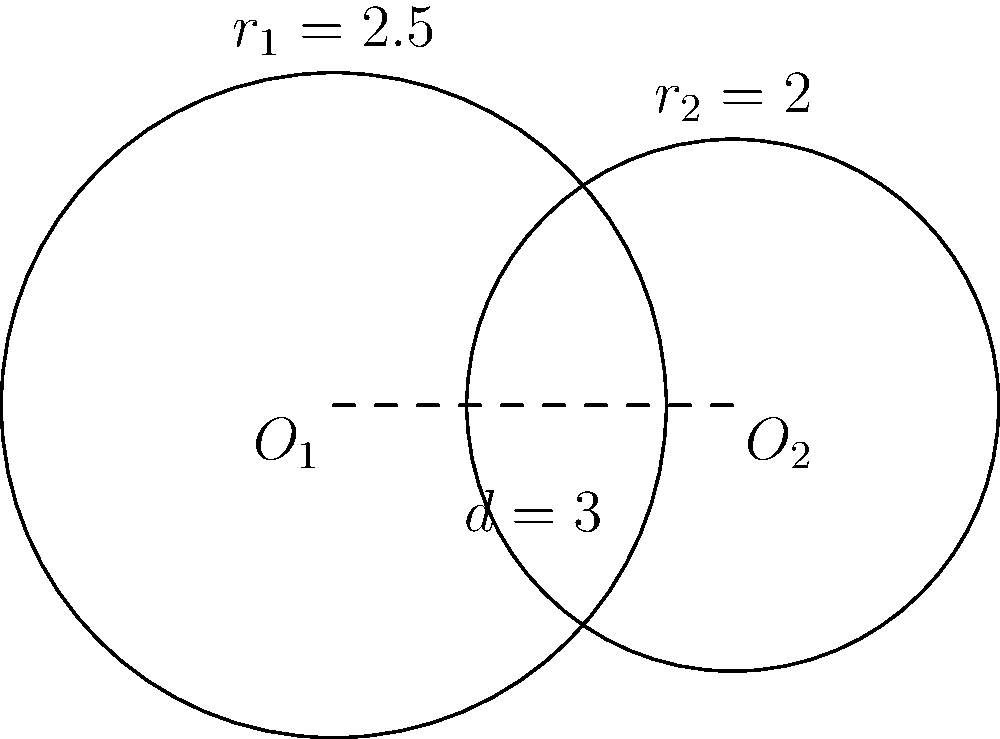In a groundbreaking investigative report by Elói Zorzetto, two circular surveillance zones are depicted as intersecting circles. The centers of these circles, $O_1$ and $O_2$, are 3 units apart. The radius of the larger circle ($r_1$) is 2.5 units, while the radius of the smaller circle ($r_2$) is 2 units. Calculate the area of the overlapping region between these two surveillance zones. To find the area of overlap between two intersecting circles, we'll follow these steps:

1) First, we need to calculate the angle $\theta$ at the center of each circle formed by the line joining the centers and the line to an intersection point.

   For circle 1: $\cos \theta_1 = \frac{r_1^2 + d^2 - r_2^2}{2r_1d}$
   
   For circle 2: $\cos \theta_2 = \frac{r_2^2 + d^2 - r_1^2}{2r_2d}$

   Where $d$ is the distance between centers.

2) Calculate $\theta_1$:
   $\cos \theta_1 = \frac{2.5^2 + 3^2 - 2^2}{2(2.5)(3)} = \frac{6.25 + 9 - 4}{15} = \frac{11.25}{15} = 0.75$
   $\theta_1 = \arccos(0.75) \approx 0.7227$ radians

3) Calculate $\theta_2$:
   $\cos \theta_2 = \frac{2^2 + 3^2 - 2.5^2}{2(2)(3)} = \frac{4 + 9 - 6.25}{12} = \frac{6.75}{12} = 0.5625$
   $\theta_2 = \arccos(0.5625) \approx 0.9828$ radians

4) The area of overlap is the sum of two sectors minus the area of two triangles:

   Area = $r_1^2 \theta_1 + r_2^2 \theta_2 - \frac{1}{2}r_1^2 \sin(2\theta_1) - \frac{1}{2}r_2^2 \sin(2\theta_2)$

5) Substituting the values:
   Area = $2.5^2(0.7227) + 2^2(0.9828) - \frac{1}{2}(2.5^2)\sin(2(0.7227)) - \frac{1}{2}(2^2)\sin(2(0.9828))$
        $\approx 4.5169 + 3.9312 - 2.0335 - 1.7512$
        $\approx 4.6634$ square units

Therefore, the area of overlap is approximately 4.6634 square units.
Answer: 4.6634 square units 